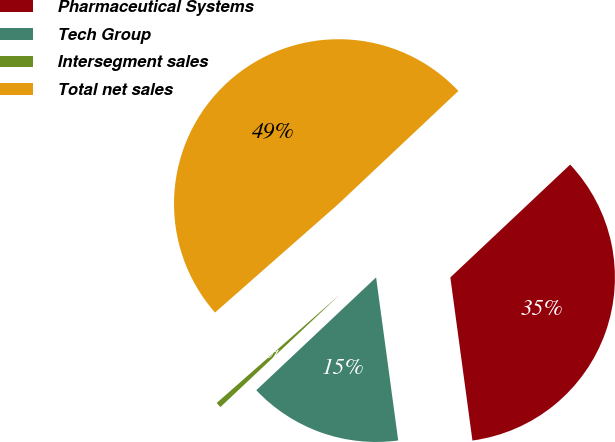Convert chart to OTSL. <chart><loc_0><loc_0><loc_500><loc_500><pie_chart><fcel>Pharmaceutical Systems<fcel>Tech Group<fcel>Intersegment sales<fcel>Total net sales<nl><fcel>34.88%<fcel>15.12%<fcel>0.54%<fcel>49.46%<nl></chart> 